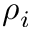<formula> <loc_0><loc_0><loc_500><loc_500>\rho _ { i }</formula> 